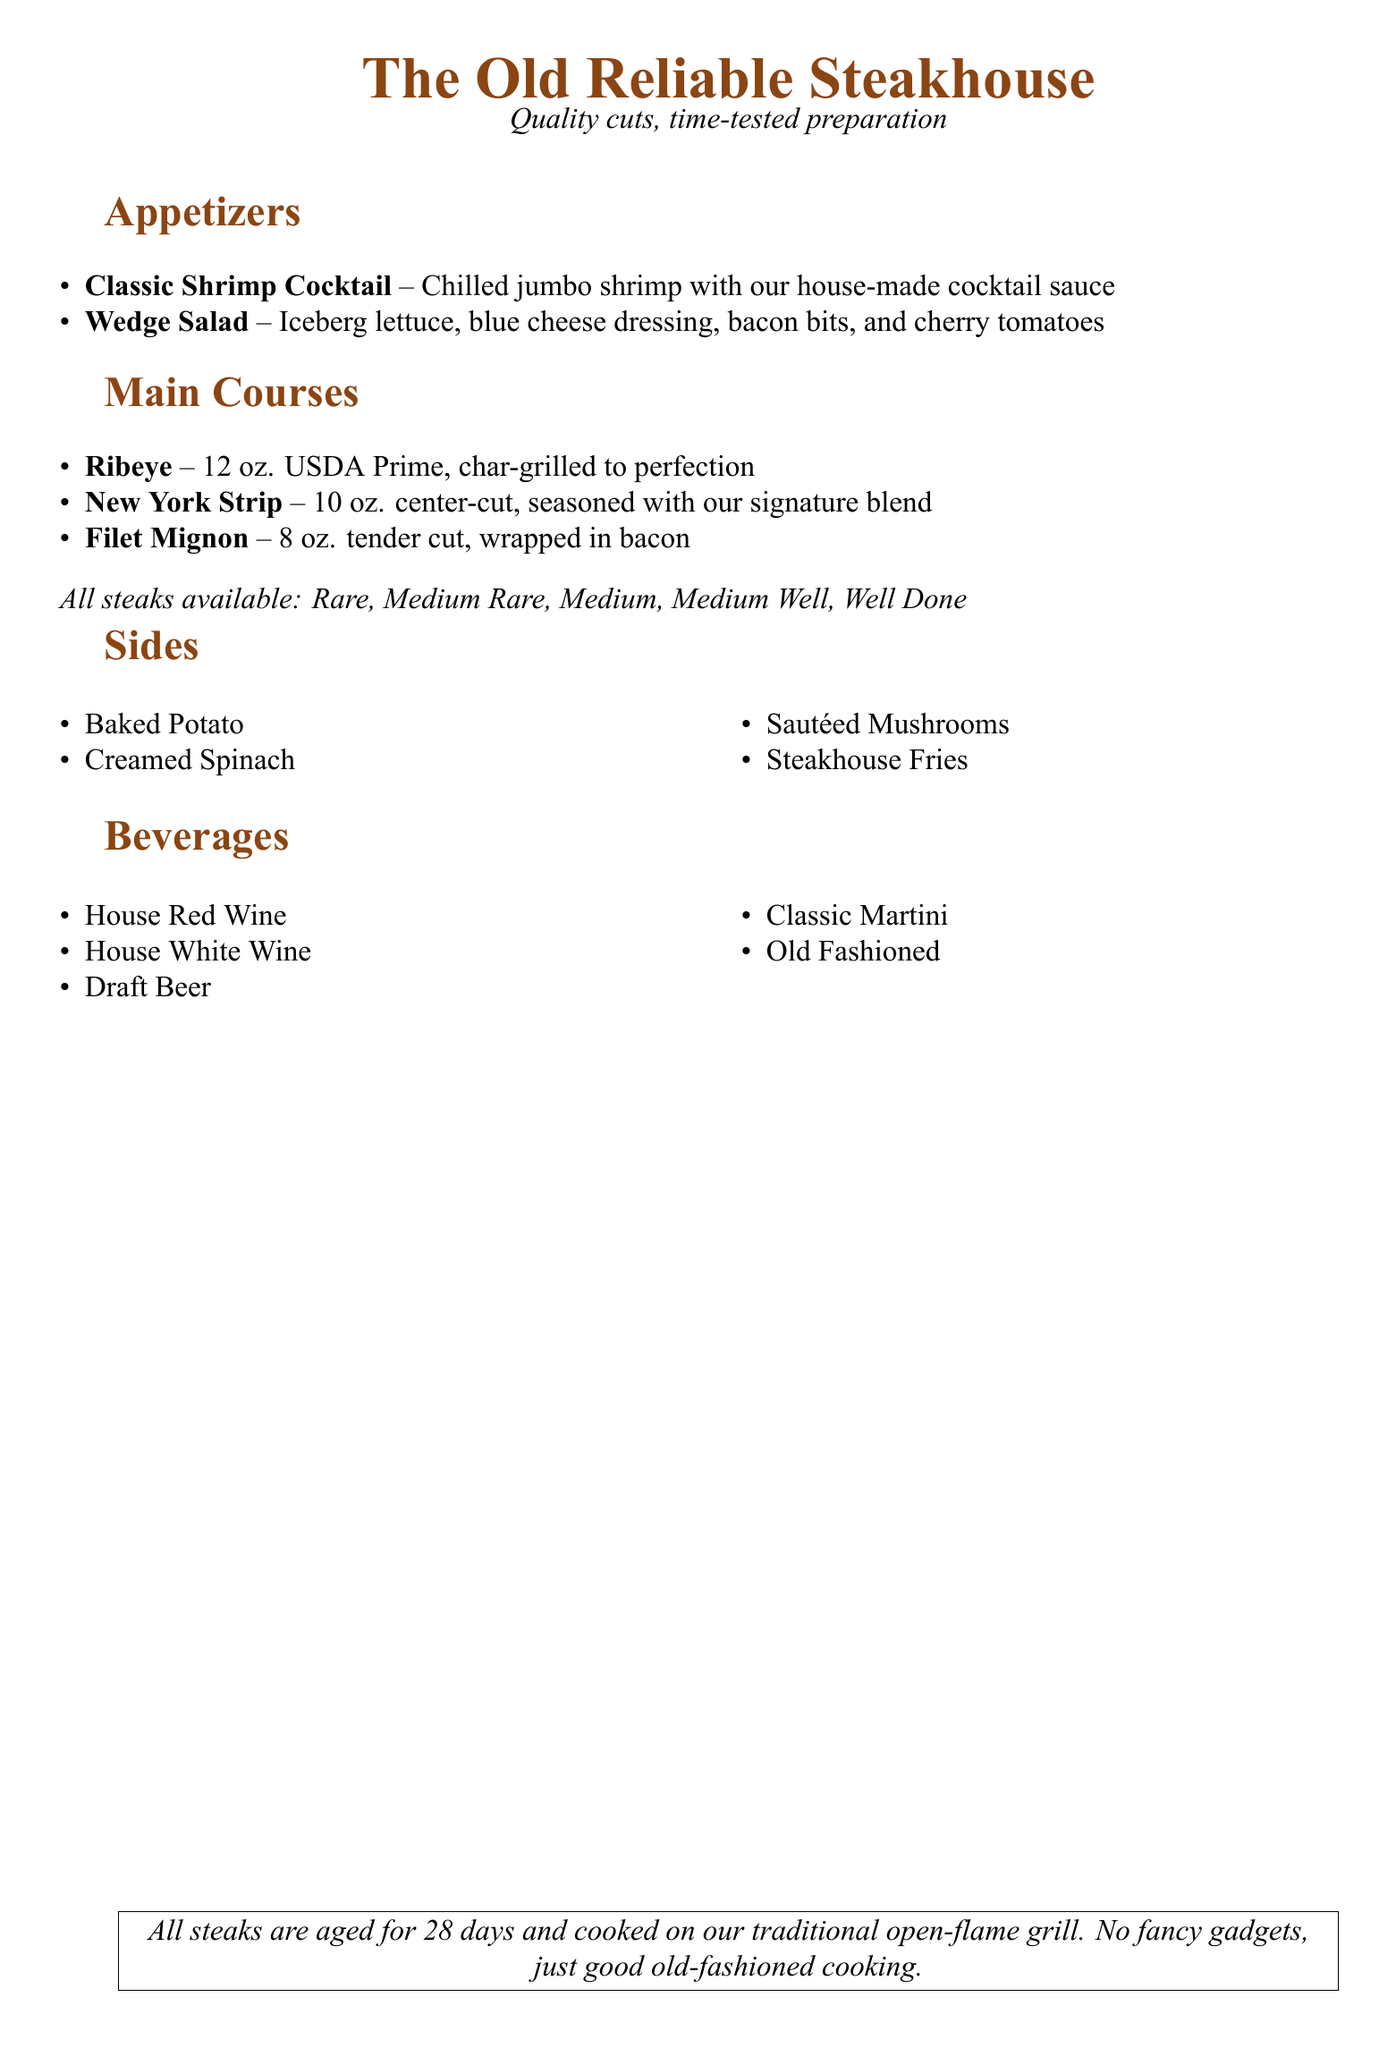What is the name of the steakhouse? The name of the steakhouse is prominently displayed at the top of the document.
Answer: The Old Reliable Steakhouse How many ounces is the Ribeye steak? The Ribeye steak section lists the weight of the steak.
Answer: 12 oz What is the price of the Filet Mignon? The steak menu does not explicitly include prices; specifically looking for the Filet Mignon, the weight is noted.
Answer: 8 oz Which side dish features spinach? The sides section includes a dish that contains spinach.
Answer: Creamed Spinach What type of cooking method is used for all steaks? A note at the bottom mentions the cooking method employed for steaks.
Answer: Traditional open-flame grill How many different steak options are available? The main courses section lists the types of steaks available.
Answer: Three What is the preparation style of the Classic Shrimp Cocktail? The appetizer section describes the serving style of this dish.
Answer: Chilled What is the house red wine? The beverages section lists drinks without specifying brands, so 'house red' refers to a generic offering.
Answer: House Red Wine What is a traditional drink featured on the menu? The beverages section lists traditional drinks that are commonly known.
Answer: Old Fashioned 